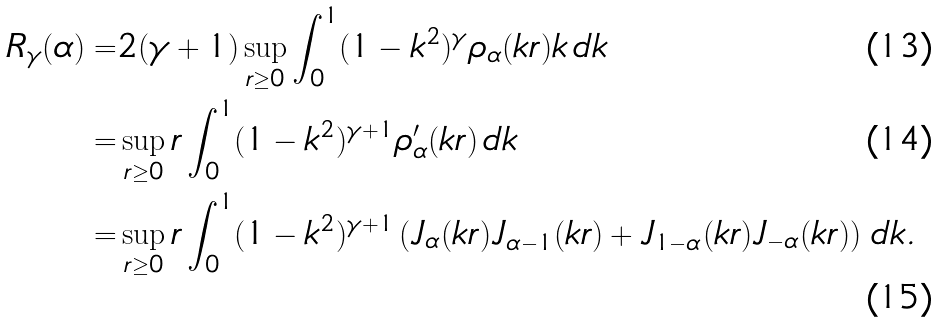<formula> <loc_0><loc_0><loc_500><loc_500>R _ { \gamma } ( \alpha ) = & 2 ( \gamma + 1 ) \sup _ { r \geq 0 } \int _ { 0 } ^ { 1 } ( 1 - k ^ { 2 } ) ^ { \gamma } \rho _ { \alpha } ( k r ) k \, d k \\ = & \sup _ { r \geq 0 } r \int _ { 0 } ^ { 1 } ( 1 - k ^ { 2 } ) ^ { \gamma + 1 } \rho _ { \alpha } ^ { \prime } ( k r ) \, d k \\ = & \sup _ { r \geq 0 } r \int _ { 0 } ^ { 1 } ( 1 - k ^ { 2 } ) ^ { \gamma + 1 } \left ( J _ { \alpha } ( k r ) J _ { \alpha - 1 } ( k r ) + J _ { 1 - \alpha } ( k r ) J _ { - \alpha } ( k r ) \right ) \, d k .</formula> 